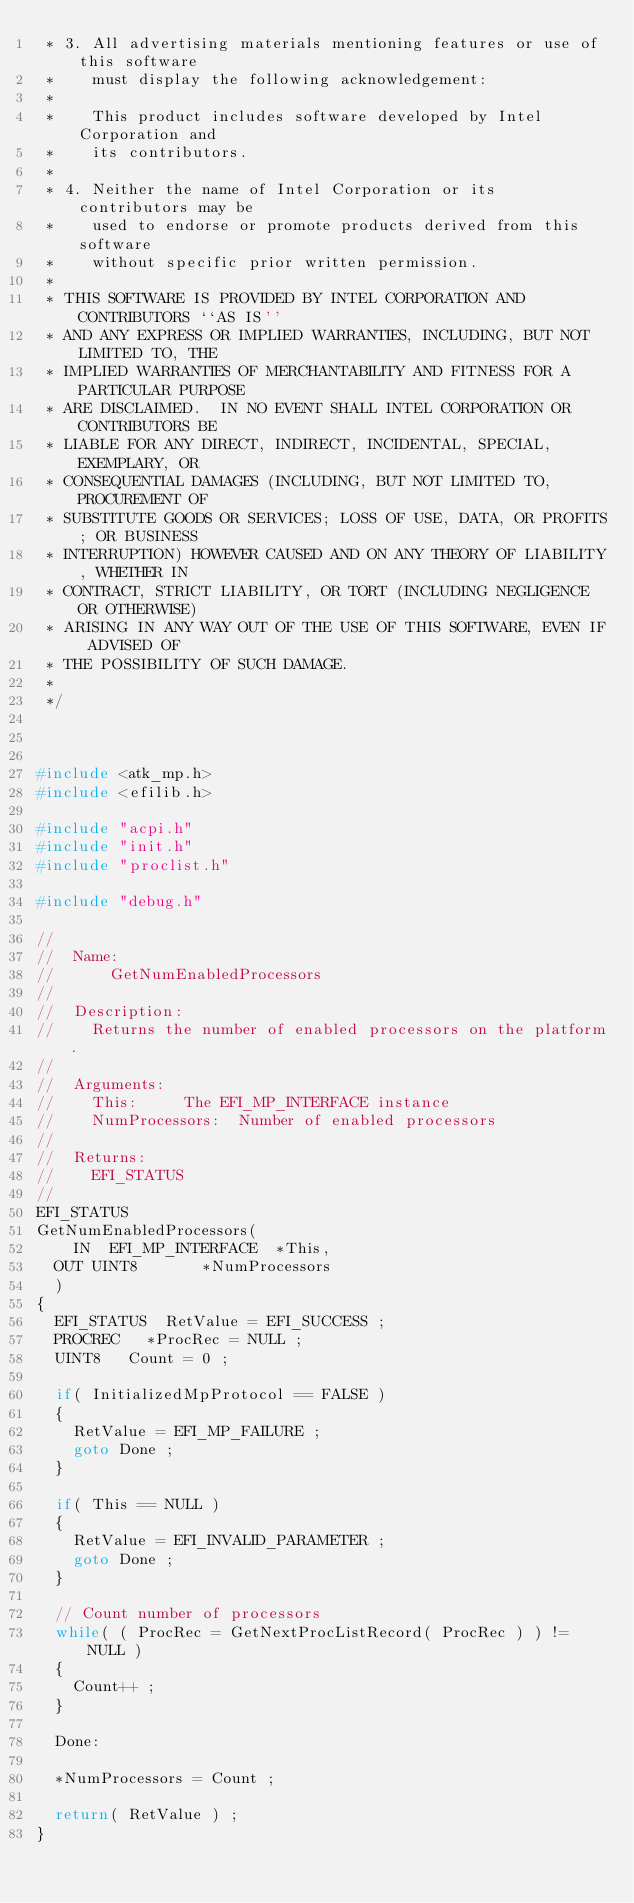<code> <loc_0><loc_0><loc_500><loc_500><_C_> * 3. All advertising materials mentioning features or use of this software
 *    must display the following acknowledgement:
 * 
 *    This product includes software developed by Intel Corporation and
 *    its contributors.
 * 
 * 4. Neither the name of Intel Corporation or its contributors may be
 *    used to endorse or promote products derived from this software
 *    without specific prior written permission.
 * 
 * THIS SOFTWARE IS PROVIDED BY INTEL CORPORATION AND CONTRIBUTORS ``AS IS''
 * AND ANY EXPRESS OR IMPLIED WARRANTIES, INCLUDING, BUT NOT LIMITED TO, THE
 * IMPLIED WARRANTIES OF MERCHANTABILITY AND FITNESS FOR A PARTICULAR PURPOSE
 * ARE DISCLAIMED.  IN NO EVENT SHALL INTEL CORPORATION OR CONTRIBUTORS BE
 * LIABLE FOR ANY DIRECT, INDIRECT, INCIDENTAL, SPECIAL, EXEMPLARY, OR
 * CONSEQUENTIAL DAMAGES (INCLUDING, BUT NOT LIMITED TO, PROCUREMENT OF
 * SUBSTITUTE GOODS OR SERVICES; LOSS OF USE, DATA, OR PROFITS; OR BUSINESS
 * INTERRUPTION) HOWEVER CAUSED AND ON ANY THEORY OF LIABILITY, WHETHER IN
 * CONTRACT, STRICT LIABILITY, OR TORT (INCLUDING NEGLIGENCE OR OTHERWISE)
 * ARISING IN ANY WAY OUT OF THE USE OF THIS SOFTWARE, EVEN IF ADVISED OF
 * THE POSSIBILITY OF SUCH DAMAGE.
 * 
 */



#include <atk_mp.h>
#include <efilib.h>

#include "acpi.h"
#include "init.h"
#include "proclist.h"

#include "debug.h"

//
//  Name:
//      GetNumEnabledProcessors
//
//  Description:
//		Returns the number of enabled processors on the platform.
//
//  Arguments:
//		This:			The EFI_MP_INTERFACE instance
//		NumProcessors:	Number of enabled processors
//
//  Returns:
//		EFI_STATUS
//
EFI_STATUS
GetNumEnabledProcessors(
    IN  EFI_MP_INTERFACE	*This,
	OUT	UINT8				*NumProcessors
	)
{
	EFI_STATUS	RetValue = EFI_SUCCESS ;
	PROCREC		*ProcRec = NULL ;
	UINT8		Count = 0 ;

	if( InitializedMpProtocol == FALSE )
	{
		RetValue = EFI_MP_FAILURE ;
		goto Done ;
	}

	if( This == NULL )
	{
		RetValue = EFI_INVALID_PARAMETER ;
		goto Done ;
	}

	// Count number of processors
	while( ( ProcRec = GetNextProcListRecord( ProcRec ) ) != NULL )
	{
		Count++ ;
	}

	Done:

	*NumProcessors = Count ;

	return( RetValue ) ;
}
</code> 